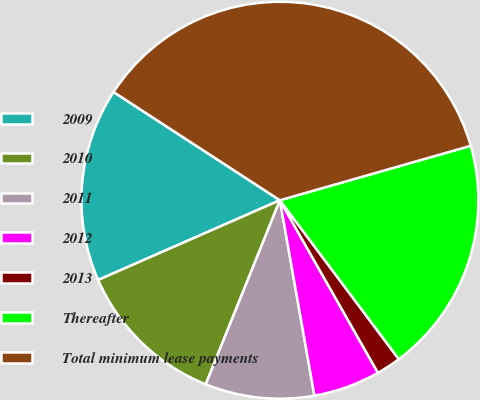Convert chart. <chart><loc_0><loc_0><loc_500><loc_500><pie_chart><fcel>2009<fcel>2010<fcel>2011<fcel>2012<fcel>2013<fcel>Thereafter<fcel>Total minimum lease payments<nl><fcel>15.76%<fcel>12.32%<fcel>8.88%<fcel>5.44%<fcel>2.0%<fcel>19.2%<fcel>36.39%<nl></chart> 